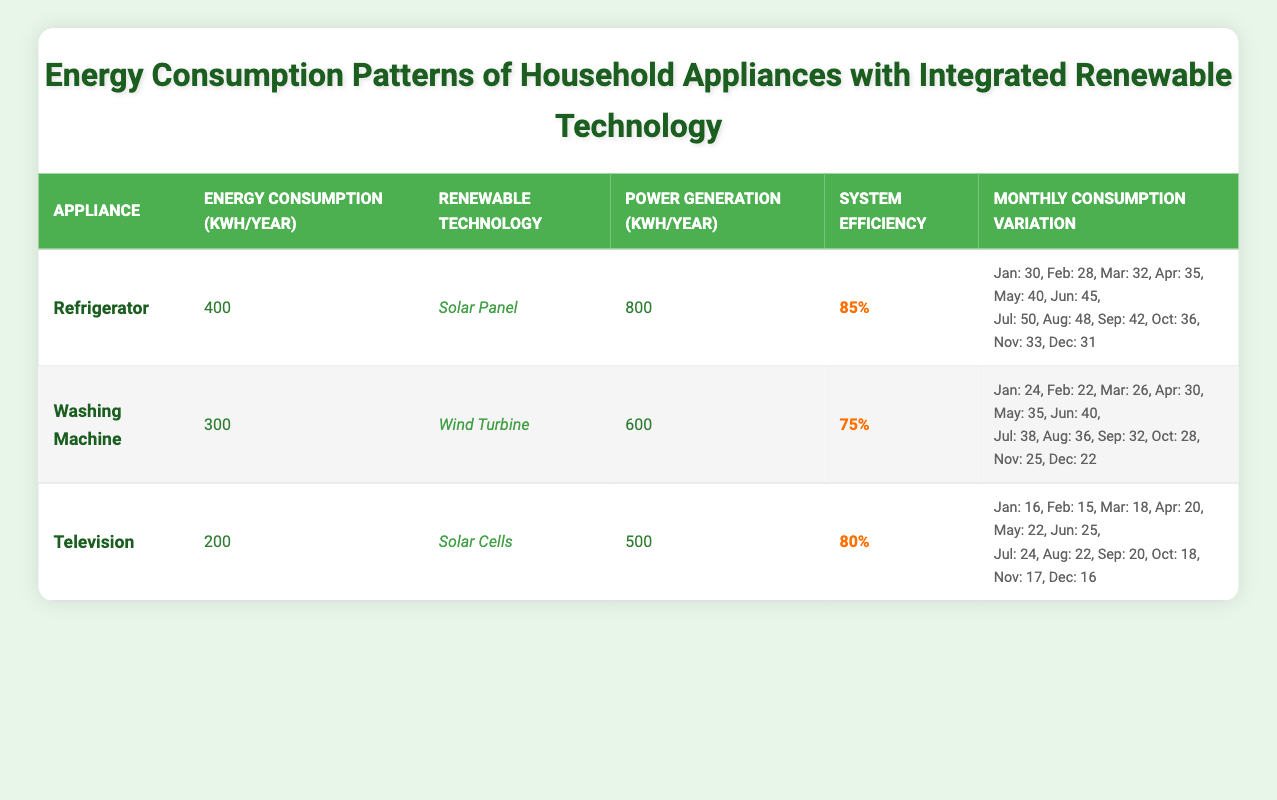What is the energy consumption of the refrigerator in kWh per year? The table indicates that the energy consumption of the refrigerator is specified directly under the "Energy Consumption (kWh/Year)" column. The value provided is 400 kWh.
Answer: 400 kWh Which renewable technology is integrated with the washing machine? The table lists the type of integrated renewable technology under the "Renewable Technology" column for each appliance. For the washing machine, it states "Wind Turbine".
Answer: Wind Turbine What is the total power generation from the refrigerator and washing machine combined? To find the total power generation from both the refrigerator and washing machine, we sum their respective power generation values: Refrigerator (800 kWh) + Washing Machine (600 kWh) = 1400 kWh.
Answer: 1400 kWh Is the system efficiency of the television greater than that of the washing machine? The system efficiency for the television is listed as 80%, while for the washing machine, it is 75%. Since 80% is greater than 75%, the answer is yes.
Answer: Yes Which appliance has the highest monthly energy consumption in July, and what is that consumption value? By reviewing the "Monthly Consumption Variation" data, we see the refrigerator consumes 50 kWh, the washing machine uses 38 kWh, and the television has 24 kWh in July. The highest among these is the refrigerator at 50 kWh.
Answer: Refrigerator, 50 kWh What percentage of the refrigerator's energy consumption can be generated annually by its integrated renewable technology? We calculate the percentage by dividing the renewable power generation by the refrigerator's energy consumption and multiply by 100: (800 kWh / 400 kWh) * 100 = 200%. Therefore, this indicates that the refrigerator can generate double its energy consumption.
Answer: 200% How many more kWh does the washing machine consume in June compared to February? The energy consumption for the washing machine in June is 40 kWh, while in February it is 22 kWh. The difference is calculated as: 40 kWh - 22 kWh = 18 kWh.
Answer: 18 kWh What is the average monthly consumption of the television over the year? To get the average, we first sum the monthly consumptions (16+15+18+20+22+25+24+22+20+18+17+16) =  21 and then divide by 12 months to get the average:  21 kWh / 12 ≈ 17.5 kWh per month.
Answer: Approximately 17.5 kWh per month Which household appliance has the lowest energy consumption per year, and what is that value? Looking at the "Energy Consumption (kWh/Year)" values, the washing machine has the lowest consumption at 300 kWh per year. Therefore, the appliance with the least energy consumption is the washing machine.
Answer: Washing Machine, 300 kWh 